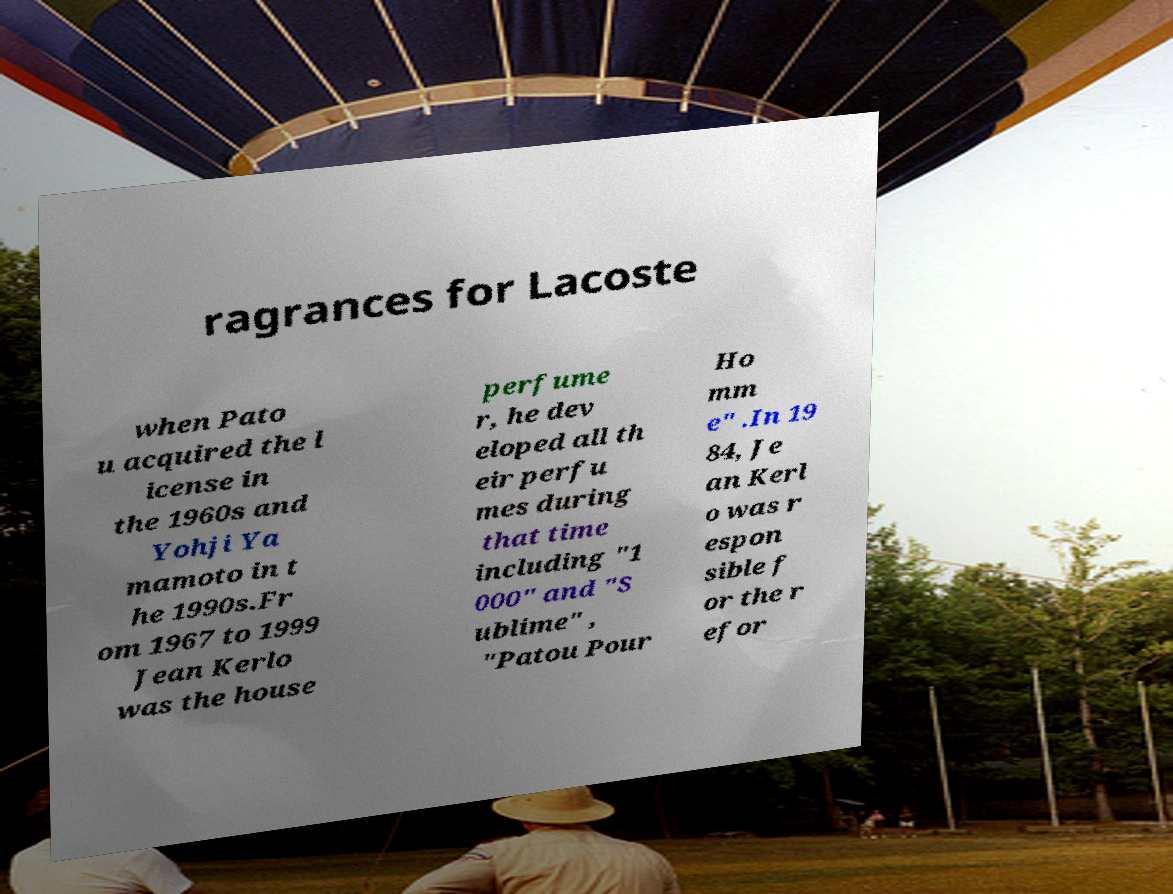Please identify and transcribe the text found in this image. ragrances for Lacoste when Pato u acquired the l icense in the 1960s and Yohji Ya mamoto in t he 1990s.Fr om 1967 to 1999 Jean Kerlo was the house perfume r, he dev eloped all th eir perfu mes during that time including "1 000" and "S ublime" , "Patou Pour Ho mm e" .In 19 84, Je an Kerl o was r espon sible f or the r efor 